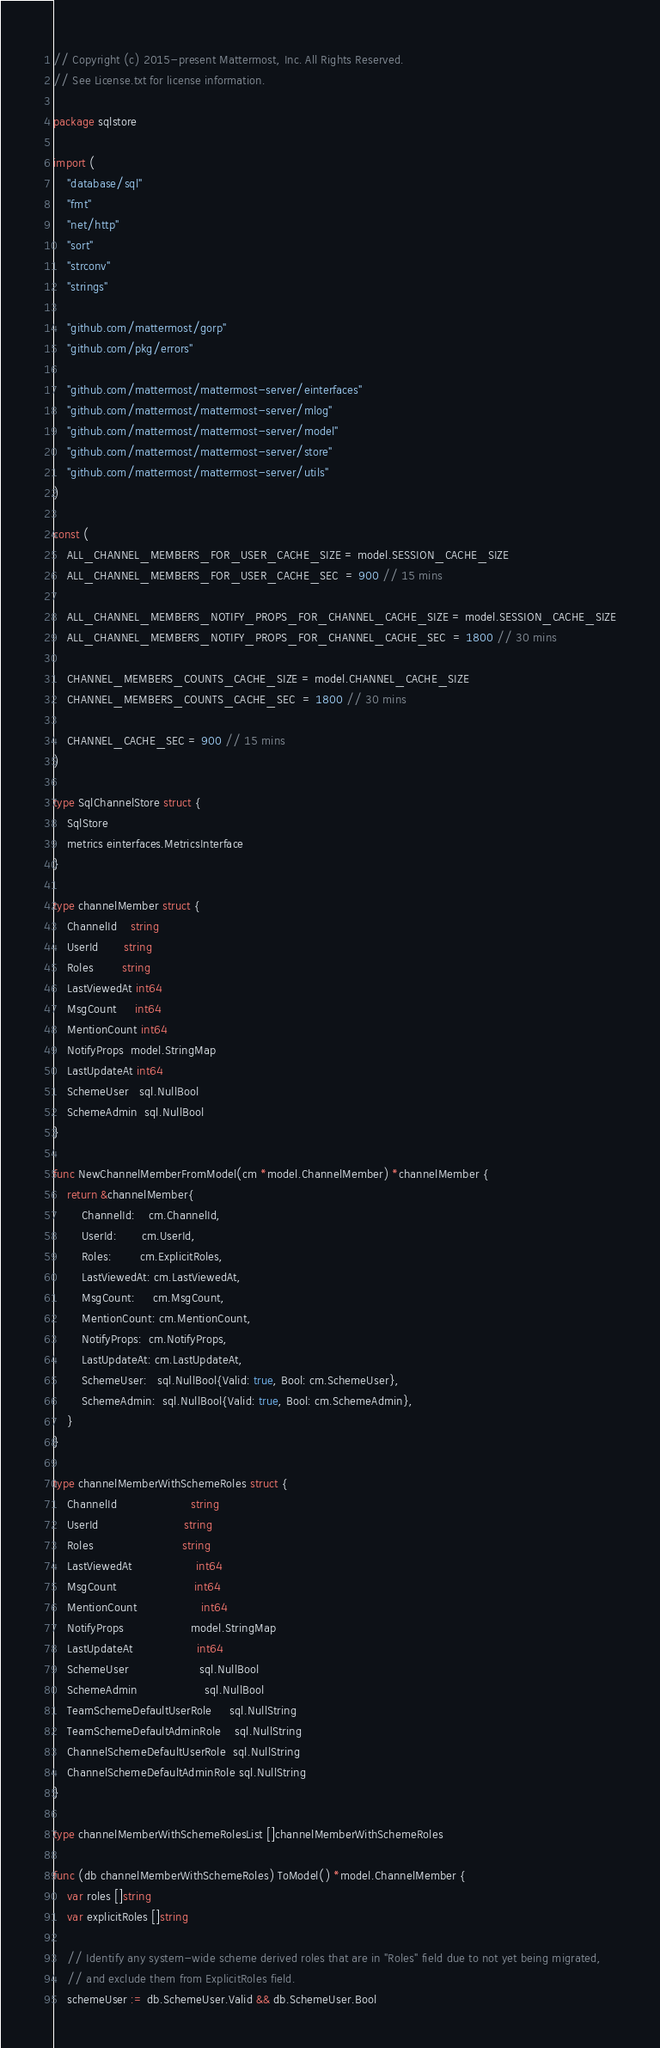<code> <loc_0><loc_0><loc_500><loc_500><_Go_>// Copyright (c) 2015-present Mattermost, Inc. All Rights Reserved.
// See License.txt for license information.

package sqlstore

import (
	"database/sql"
	"fmt"
	"net/http"
	"sort"
	"strconv"
	"strings"

	"github.com/mattermost/gorp"
	"github.com/pkg/errors"

	"github.com/mattermost/mattermost-server/einterfaces"
	"github.com/mattermost/mattermost-server/mlog"
	"github.com/mattermost/mattermost-server/model"
	"github.com/mattermost/mattermost-server/store"
	"github.com/mattermost/mattermost-server/utils"
)

const (
	ALL_CHANNEL_MEMBERS_FOR_USER_CACHE_SIZE = model.SESSION_CACHE_SIZE
	ALL_CHANNEL_MEMBERS_FOR_USER_CACHE_SEC  = 900 // 15 mins

	ALL_CHANNEL_MEMBERS_NOTIFY_PROPS_FOR_CHANNEL_CACHE_SIZE = model.SESSION_CACHE_SIZE
	ALL_CHANNEL_MEMBERS_NOTIFY_PROPS_FOR_CHANNEL_CACHE_SEC  = 1800 // 30 mins

	CHANNEL_MEMBERS_COUNTS_CACHE_SIZE = model.CHANNEL_CACHE_SIZE
	CHANNEL_MEMBERS_COUNTS_CACHE_SEC  = 1800 // 30 mins

	CHANNEL_CACHE_SEC = 900 // 15 mins
)

type SqlChannelStore struct {
	SqlStore
	metrics einterfaces.MetricsInterface
}

type channelMember struct {
	ChannelId    string
	UserId       string
	Roles        string
	LastViewedAt int64
	MsgCount     int64
	MentionCount int64
	NotifyProps  model.StringMap
	LastUpdateAt int64
	SchemeUser   sql.NullBool
	SchemeAdmin  sql.NullBool
}

func NewChannelMemberFromModel(cm *model.ChannelMember) *channelMember {
	return &channelMember{
		ChannelId:    cm.ChannelId,
		UserId:       cm.UserId,
		Roles:        cm.ExplicitRoles,
		LastViewedAt: cm.LastViewedAt,
		MsgCount:     cm.MsgCount,
		MentionCount: cm.MentionCount,
		NotifyProps:  cm.NotifyProps,
		LastUpdateAt: cm.LastUpdateAt,
		SchemeUser:   sql.NullBool{Valid: true, Bool: cm.SchemeUser},
		SchemeAdmin:  sql.NullBool{Valid: true, Bool: cm.SchemeAdmin},
	}
}

type channelMemberWithSchemeRoles struct {
	ChannelId                     string
	UserId                        string
	Roles                         string
	LastViewedAt                  int64
	MsgCount                      int64
	MentionCount                  int64
	NotifyProps                   model.StringMap
	LastUpdateAt                  int64
	SchemeUser                    sql.NullBool
	SchemeAdmin                   sql.NullBool
	TeamSchemeDefaultUserRole     sql.NullString
	TeamSchemeDefaultAdminRole    sql.NullString
	ChannelSchemeDefaultUserRole  sql.NullString
	ChannelSchemeDefaultAdminRole sql.NullString
}

type channelMemberWithSchemeRolesList []channelMemberWithSchemeRoles

func (db channelMemberWithSchemeRoles) ToModel() *model.ChannelMember {
	var roles []string
	var explicitRoles []string

	// Identify any system-wide scheme derived roles that are in "Roles" field due to not yet being migrated,
	// and exclude them from ExplicitRoles field.
	schemeUser := db.SchemeUser.Valid && db.SchemeUser.Bool</code> 